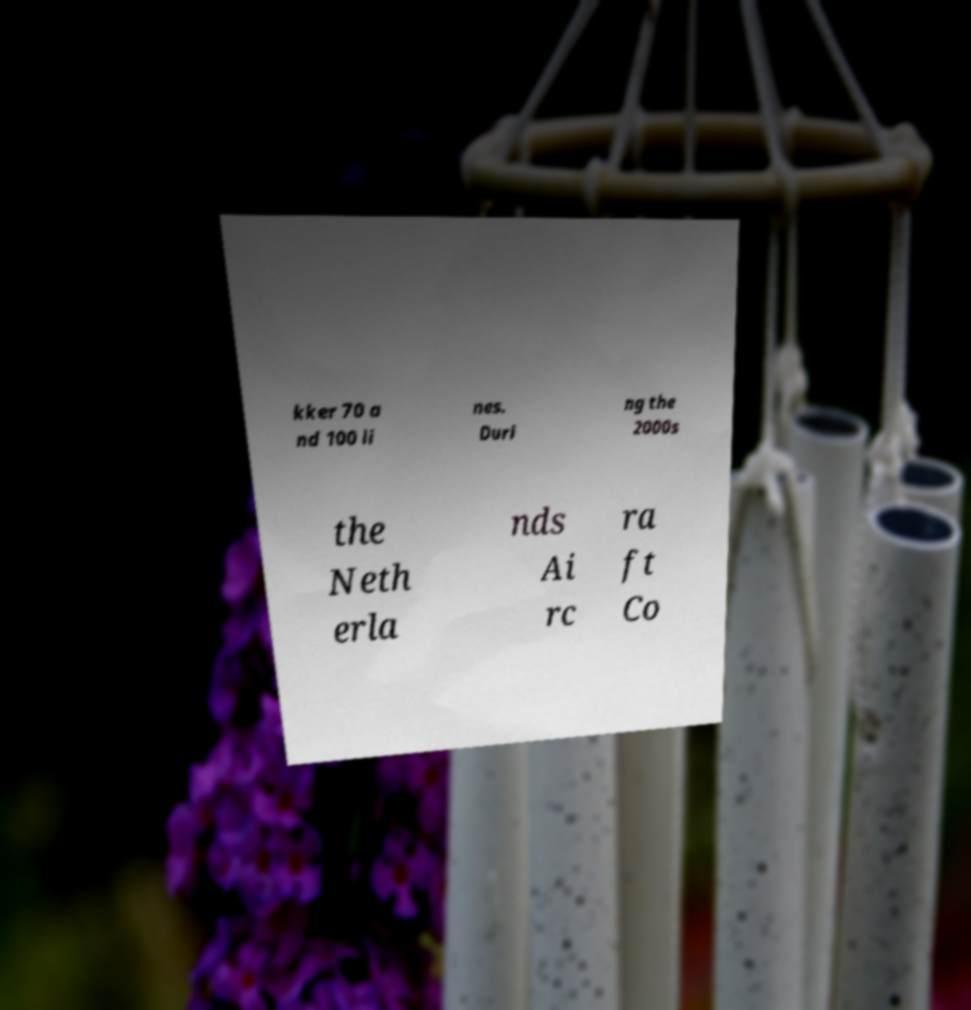Please read and relay the text visible in this image. What does it say? kker 70 a nd 100 li nes. Duri ng the 2000s the Neth erla nds Ai rc ra ft Co 